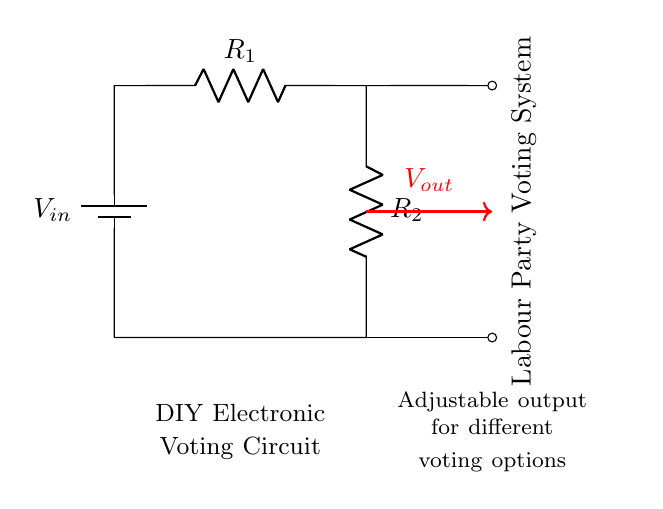What is the input voltage in the circuit? The input voltage is labeled as V_{in} in the diagram, indicating it's the voltage supplied to the circuit.
Answer: V_{in} How many resistors are in the circuit? The circuit has two resistors labeled as R_1 and R_2. Their presence is indicated by the 'to[R, ...]' notation in the code.
Answer: 2 What is the purpose of R_1 and R_2? R_1 and R_2 provide a means to divide the input voltage, allowing for a specific output voltage based on their values, creating a voltage divider.
Answer: Voltage division What does V_{out} represent in the circuit? V_{out} represents the output voltage which is taken from the junction of R_1 and R_2 in the circuit. This output is adjustable based on the resistor values.
Answer: Output voltage If R_1 is twice the value of R_2, what would be the ratio of V_{out} to V_{in}? The voltage division rule states that V_{out} = V_{in} * (R_2 / (R_1 + R_2)). If R_1 is twice R_2, then the ratio simplifies to 1/3.
Answer: 1/3 What is the significance of labeling the circuit as a "Labour Party Voting System"? The labeling indicates that the circuit is designed for a specific application, which is to collect and process votes in a local Labour Party meeting, emphasizing its practical purpose.
Answer: Specific application What can be adjusted for different voting options in this circuit? The output voltage V_{out} can be adjusted by changing the values of R_1 and R_2, which allows the circuit to handle various voting scenarios.
Answer: Resistor values 